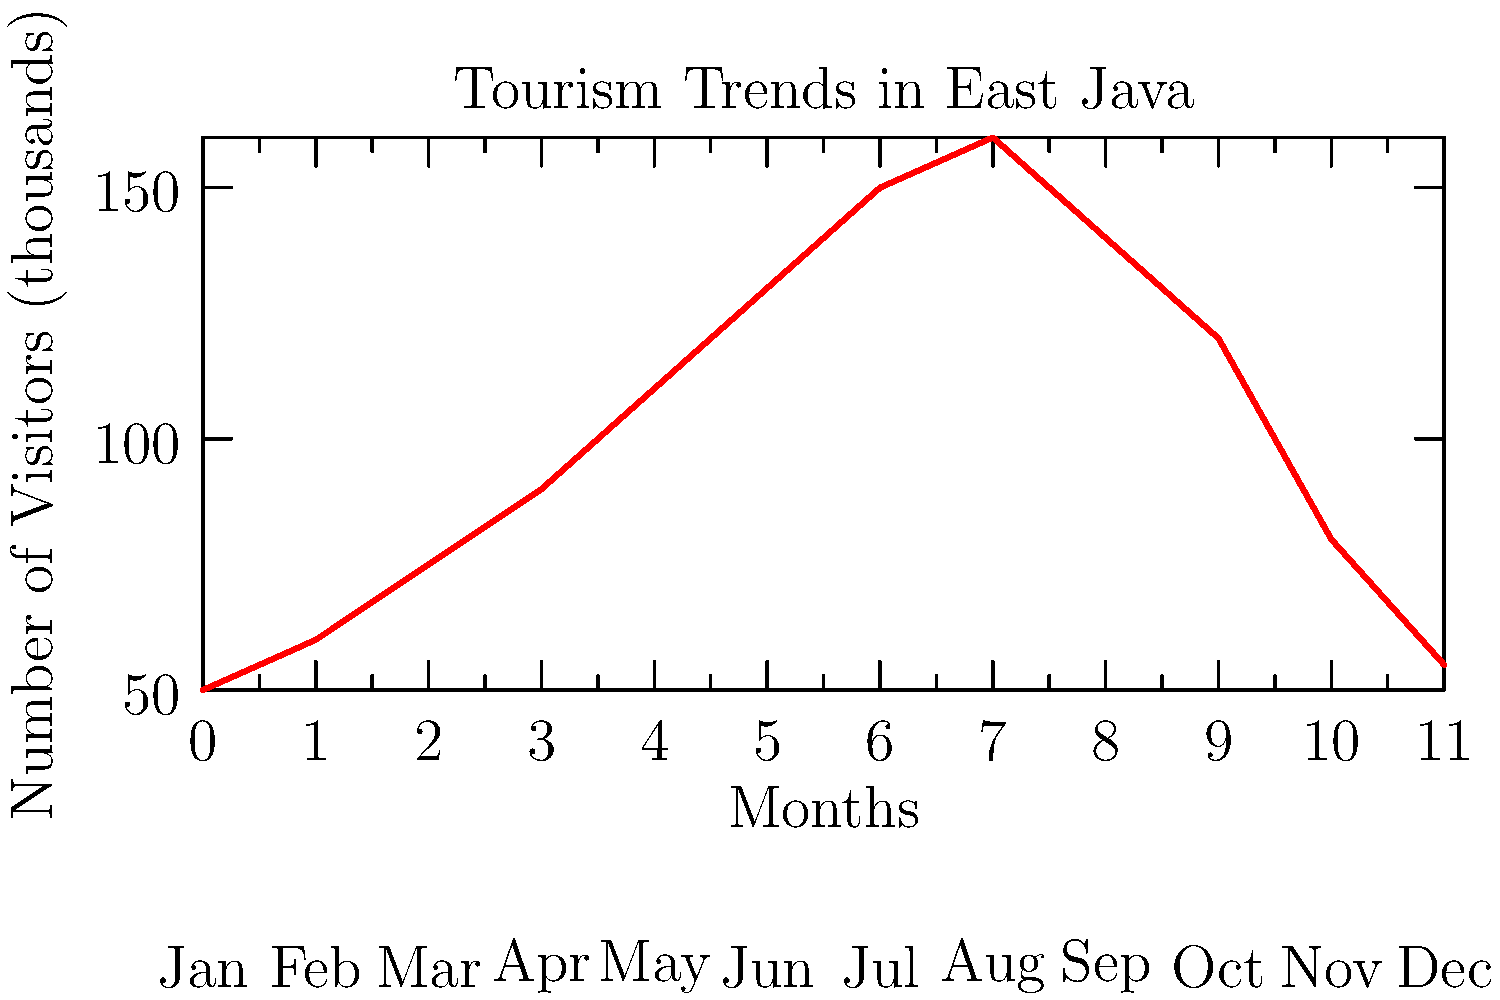As a local business owner in Gresik Regency, East Java, you're analyzing the seasonal tourism trends shown in the line graph. What is the approximate percentage increase in visitor numbers from January to the peak month, and how might this information influence your business strategy? To answer this question, we need to follow these steps:

1. Identify the starting point (January) and peak month:
   - January (start): 50,000 visitors
   - Peak month (August): 160,000 visitors

2. Calculate the percentage increase:
   $$ \text{Percentage Increase} = \frac{\text{Increase}}{\text{Original Amount}} \times 100\% $$
   $$ = \frac{160,000 - 50,000}{50,000} \times 100\% $$
   $$ = \frac{110,000}{50,000} \times 100\% $$
   $$ = 2.2 \times 100\% = 220\% $$

3. Consider the business implications:
   - The significant increase (220%) suggests a strong seasonal trend.
   - Peak season is from June to September, with August being the highest.
   - The low season is from November to February.
   - There's a gradual increase from March to May and a decrease from September to November.

4. Potential business strategies:
   - Adjust inventory and staffing levels to match seasonal demand.
   - Develop special promotions or products for the peak season.
   - Create off-season attractions or events to boost business during slower months.
   - Collaborate with tourism agencies to attract visitors year-round.
   - Consider seasonal pricing strategies to maximize revenue during peak times and maintain cash flow in off-seasons.
Answer: 220% increase; adapt inventory, staffing, and marketing strategies to seasonal fluctuations. 